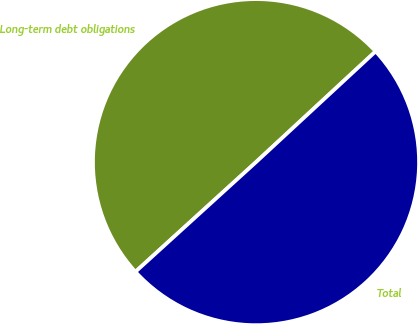<chart> <loc_0><loc_0><loc_500><loc_500><pie_chart><fcel>Long-term debt obligations<fcel>Total<nl><fcel>49.86%<fcel>50.14%<nl></chart> 